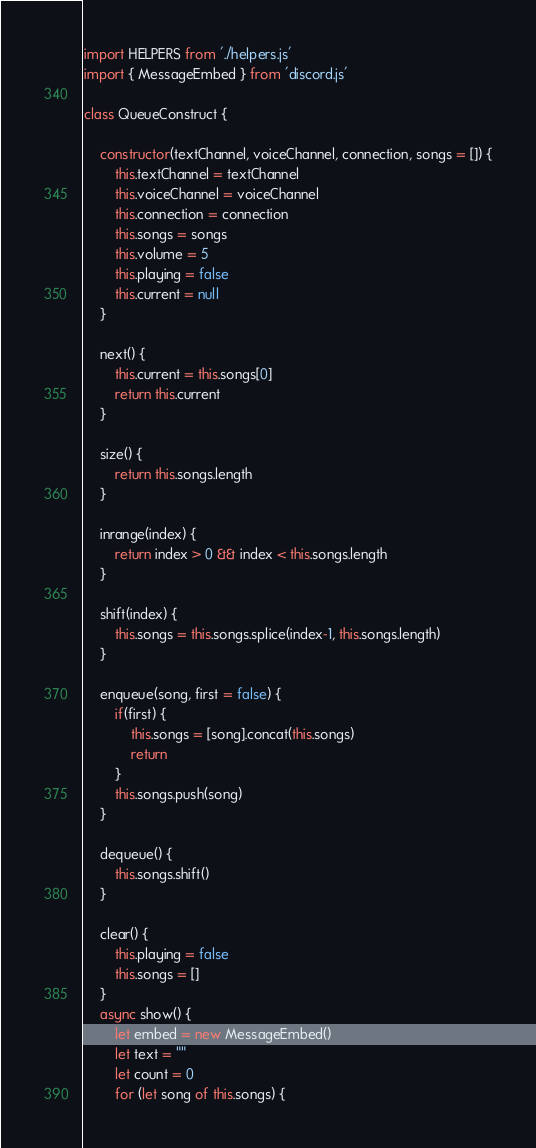Convert code to text. <code><loc_0><loc_0><loc_500><loc_500><_JavaScript_>import HELPERS from './helpers.js'
import { MessageEmbed } from 'discord.js'

class QueueConstruct {

    constructor(textChannel, voiceChannel, connection, songs = []) {
        this.textChannel = textChannel
        this.voiceChannel = voiceChannel
        this.connection = connection
        this.songs = songs
        this.volume = 5
        this.playing = false
        this.current = null
    }

    next() {
        this.current = this.songs[0]
        return this.current
    }

    size() {
        return this.songs.length
    }

    inrange(index) {
        return index > 0 && index < this.songs.length
    }

    shift(index) {
        this.songs = this.songs.splice(index-1, this.songs.length)
    }

    enqueue(song, first = false) {
        if(first) {
            this.songs = [song].concat(this.songs)
            return
        }
        this.songs.push(song)
    }

    dequeue() {
        this.songs.shift()
    }

    clear() {
        this.playing = false
        this.songs = []
    }
    async show() {
        let embed = new MessageEmbed()
        let text = ""
        let count = 0
        for (let song of this.songs) {</code> 